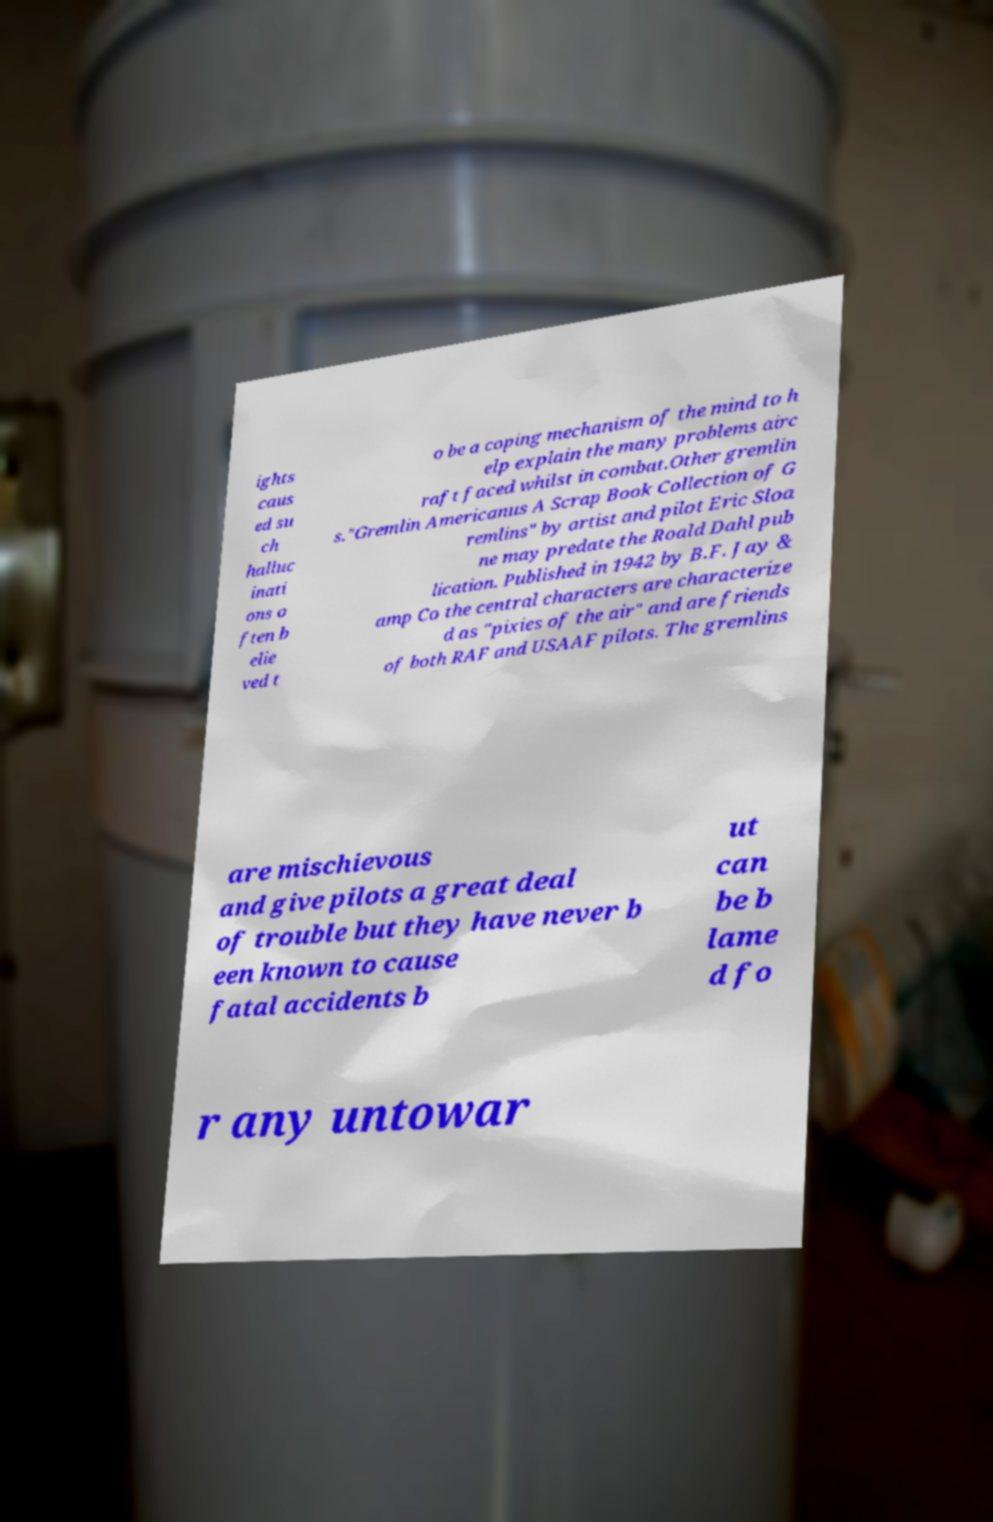I need the written content from this picture converted into text. Can you do that? ights caus ed su ch halluc inati ons o ften b elie ved t o be a coping mechanism of the mind to h elp explain the many problems airc raft faced whilst in combat.Other gremlin s."Gremlin Americanus A Scrap Book Collection of G remlins" by artist and pilot Eric Sloa ne may predate the Roald Dahl pub lication. Published in 1942 by B.F. Jay & amp Co the central characters are characterize d as "pixies of the air" and are friends of both RAF and USAAF pilots. The gremlins are mischievous and give pilots a great deal of trouble but they have never b een known to cause fatal accidents b ut can be b lame d fo r any untowar 